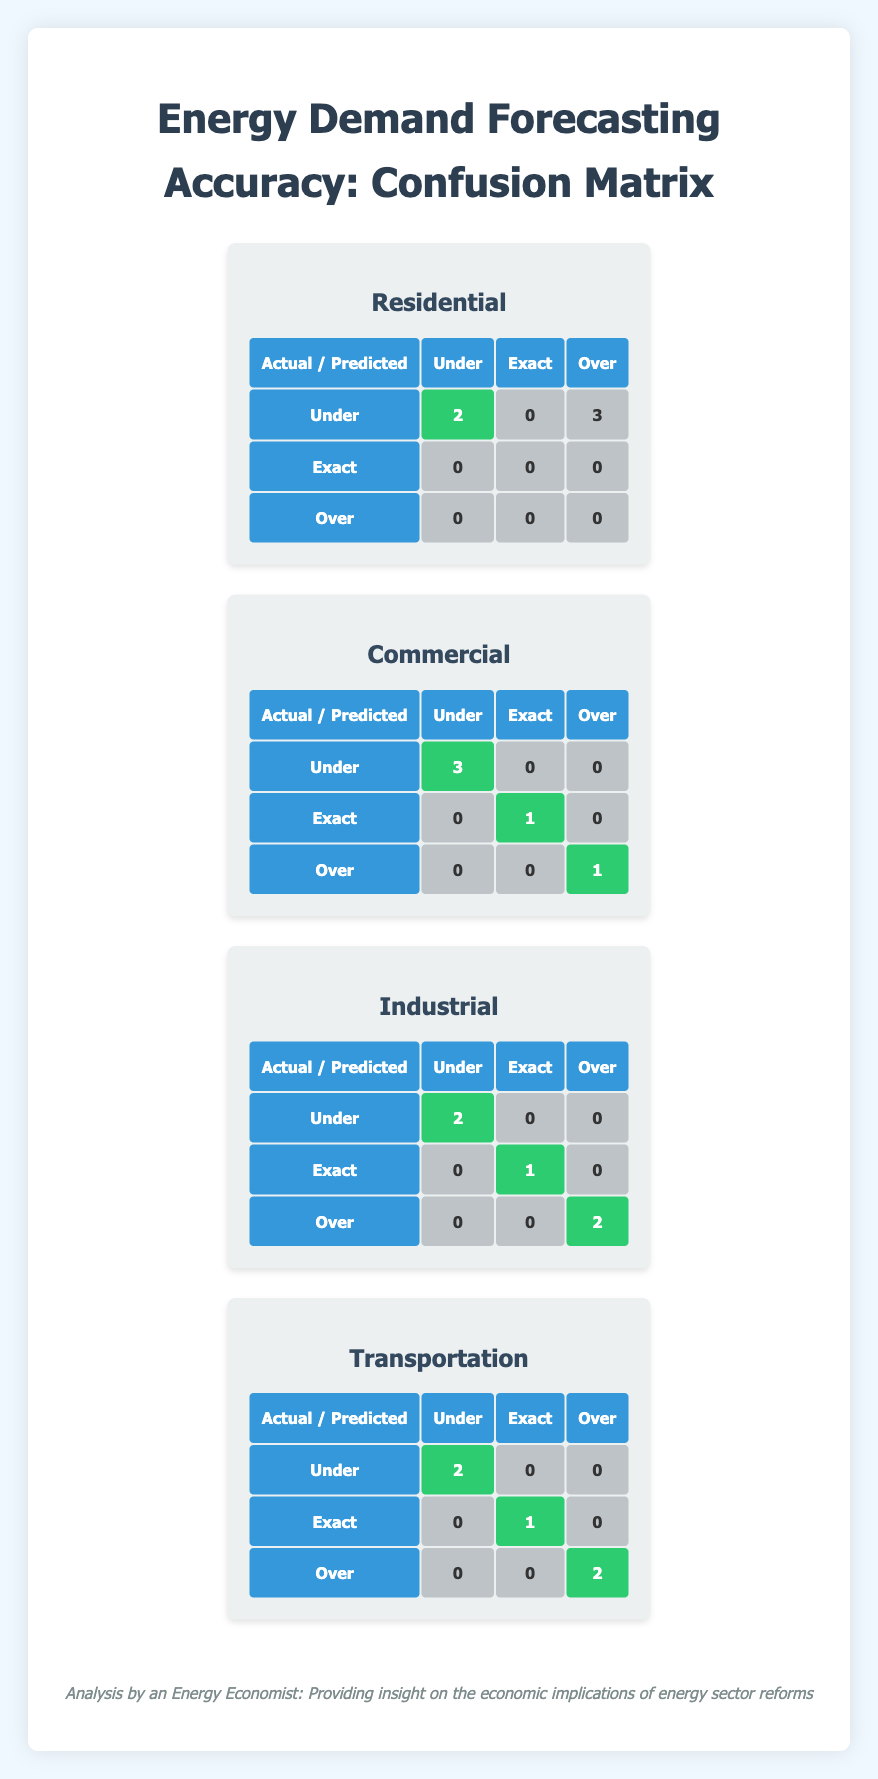What is the total number of underestimations for the Residential sector? In the confusion matrix for the Residential sector, the "Under" row shows a count of 2. This indicates that there were 2 instances where the demand was predicted as "Under."
Answer: 2 What is the accuracy of the Commercial sector forecast? The accuracy of a forecast can be calculated as (number of Exact predictions) / (total predictions). For the Commercial sector, there is 1 Exact prediction out of 5 total predictions, giving an accuracy of 1/5 = 0.2 or 20%.
Answer: 20% How many times was the demand for the Industrial sector forecasted exactly? In the confusion matrix for the Industrial sector, under the "Exact" column, there is a count of 1. This indicates that the demand was predicted exactly once.
Answer: 1 Which sector had the highest number of overestimations? By comparing the "Over" counts across all sectors: Residential (3), Commercial (1), Industrial (2), Transportation (2). The Residential sector has the highest count of overestimations at 3.
Answer: Residential Is it true that the Transportation sector had more underestimations than exact predictions? The Transportation sector confusion matrix shows 2 underestimations and 1 exact prediction. Since 2 is greater than 1, the statement is true.
Answer: Yes What is the average number of predictions classified as "Over" across all sectors? The counts for "Over" are as follows: Residential (3), Commercial (1), Industrial (2), Transportation (2). Summing these gives 3 + 1 + 2 + 2 = 8. There are 4 sectors, so the average is 8/4 = 2.
Answer: 2 How many total predictions were classified as "Exact" across all sectors? Adding the counts from each sector for "Exact": Residential (0), Commercial (1), Industrial (1), Transportation (1) results in a total of 0 + 1 + 1 + 1 = 3.
Answer: 3 Which sector had the least number of underestimations? Reviewing the counts for "Under" in the confusion matrices: Residential (2), Commercial (3), Industrial (2), Transportation (2). The sector with the least number of underestimations is Industrial (2 is tied but appears lowest first).
Answer: Industrial How many predictions in the Industrial sector were classified as "Under" or "Exact"? For the Industrial sector, "Under" has a count of 2 and "Exact" has a count of 1. Adding these gives 2 + 1 = 3.
Answer: 3 